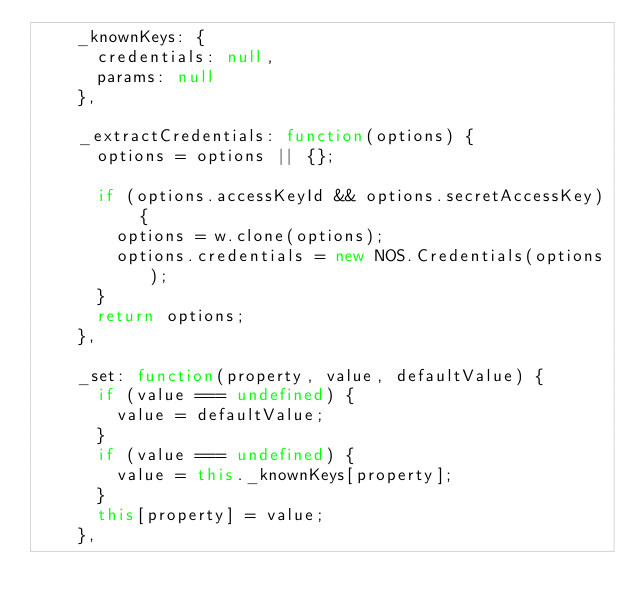Convert code to text. <code><loc_0><loc_0><loc_500><loc_500><_JavaScript_>    _knownKeys: {
      credentials: null,
      params: null
    },

    _extractCredentials: function(options) {
      options = options || {};

      if (options.accessKeyId && options.secretAccessKey) {
        options = w.clone(options);
        options.credentials = new NOS.Credentials(options);
      }
      return options;
    },

    _set: function(property, value, defaultValue) {
      if (value === undefined) {
        value = defaultValue;
      }
      if (value === undefined) {
        value = this._knownKeys[property];
      }
      this[property] = value;
    },
</code> 